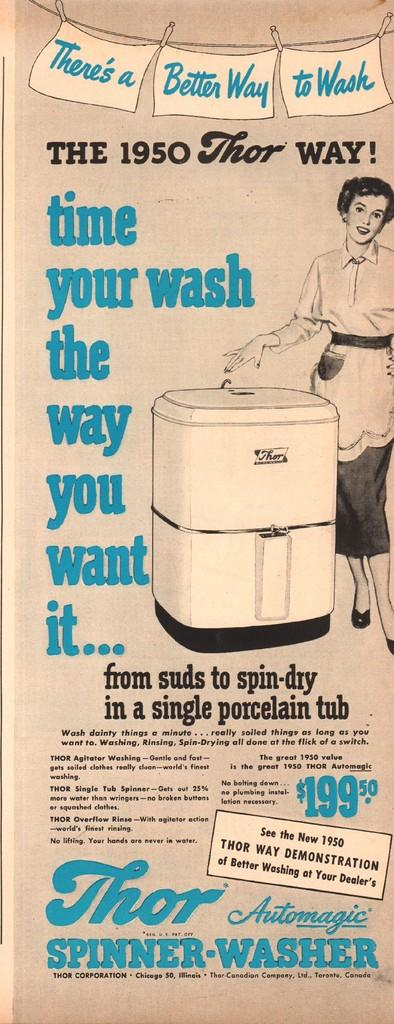<image>
Provide a brief description of the given image. A poster advertising the Thor spinner washer with a smiley woman on it. 